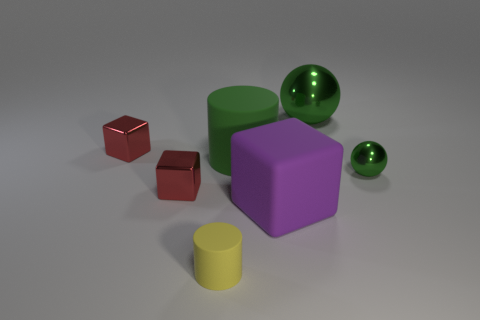What material is the other ball that is the same color as the tiny metallic ball?
Offer a terse response. Metal. There is a large cylinder; does it have the same color as the small metallic object on the right side of the large purple block?
Your answer should be compact. Yes. Are the small ball and the large green object right of the large purple block made of the same material?
Keep it short and to the point. Yes. How many things are tiny green metallic balls or small red matte things?
Your answer should be very brief. 1. There is a red object behind the large green rubber cylinder; does it have the same size as the metallic object in front of the small green shiny ball?
Provide a succinct answer. Yes. What number of cylinders are metal things or big shiny objects?
Ensure brevity in your answer.  0. Are any big gray matte objects visible?
Keep it short and to the point. No. Are there any other things that are the same shape as the small green metallic thing?
Give a very brief answer. Yes. Is the color of the small metal ball the same as the big cylinder?
Make the answer very short. Yes. How many objects are either tiny red shiny objects that are in front of the big cylinder or yellow shiny balls?
Offer a very short reply. 1. 